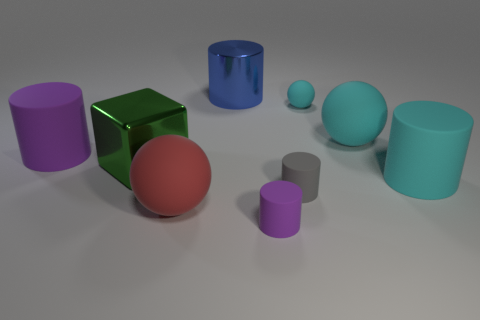There is a purple matte cylinder that is behind the tiny gray rubber cylinder; what is its size? The purple matte cylinder appears to be of medium size in relation to the other objects in the image. It is larger than the small grey cylinder in the foreground but smaller than the largest objects present. 